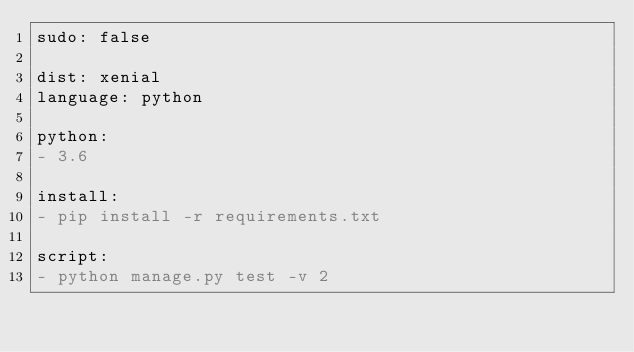<code> <loc_0><loc_0><loc_500><loc_500><_YAML_>sudo: false

dist: xenial
language: python

python:
- 3.6

install:
- pip install -r requirements.txt

script:
- python manage.py test -v 2
</code> 